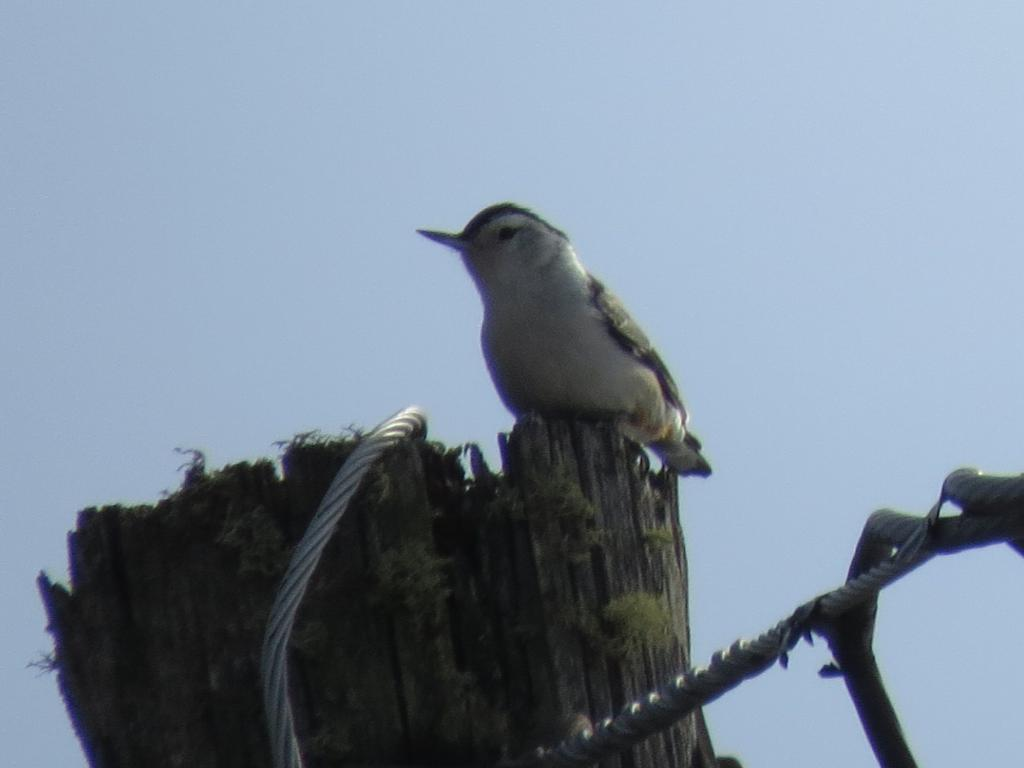What is the main subject in the middle of the image? There is a bird in the middle of the image. What else can be seen in the image besides the bird? Cables are visible in the image. What is the bird's favorite club in the image? There is no information about the bird's preferences or any clubs in the image. 